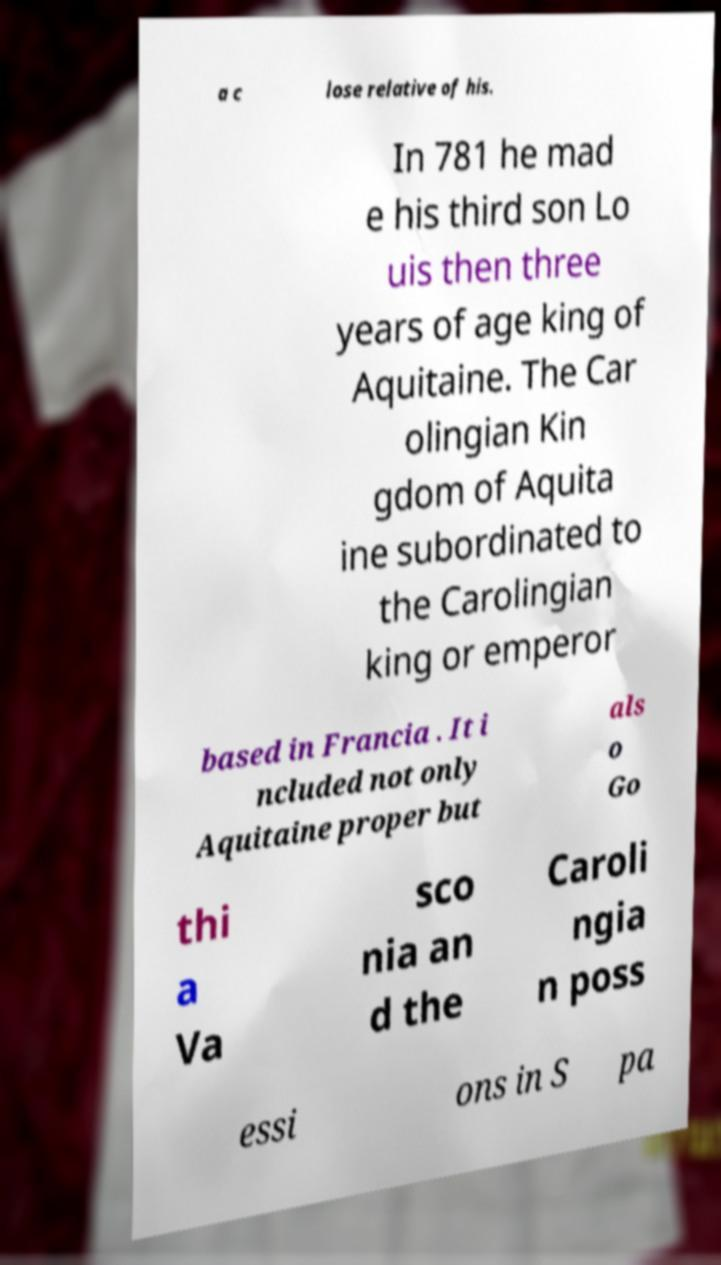Could you assist in decoding the text presented in this image and type it out clearly? a c lose relative of his. In 781 he mad e his third son Lo uis then three years of age king of Aquitaine. The Car olingian Kin gdom of Aquita ine subordinated to the Carolingian king or emperor based in Francia . It i ncluded not only Aquitaine proper but als o Go thi a Va sco nia an d the Caroli ngia n poss essi ons in S pa 